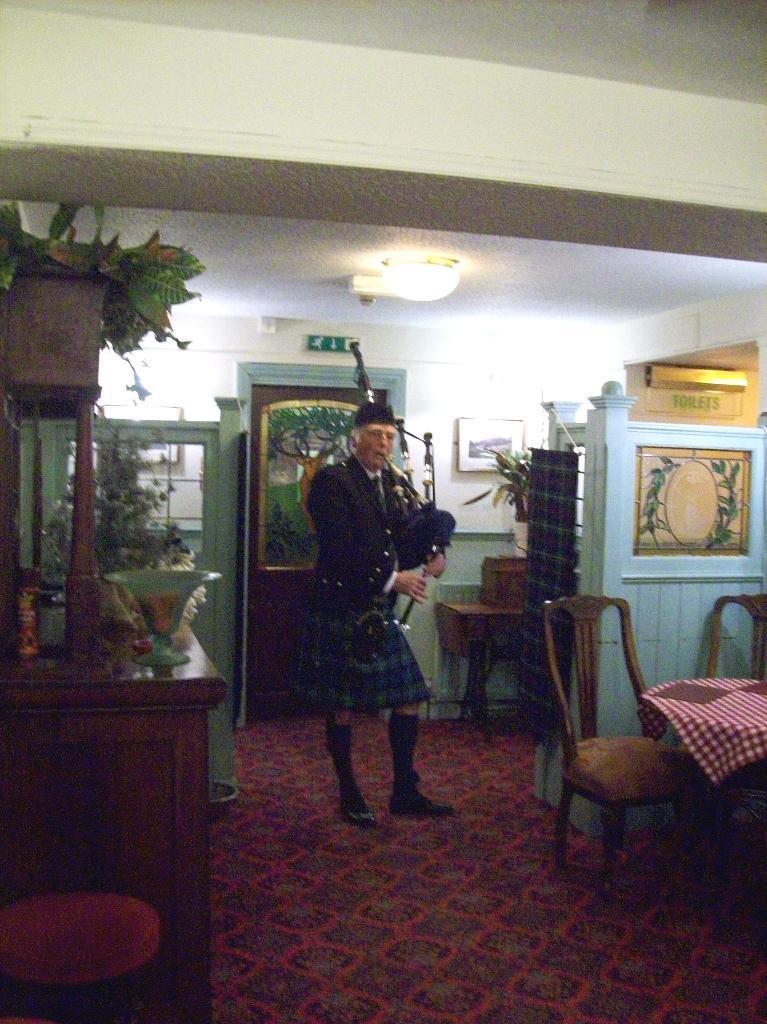How would you summarize this image in a sentence or two? In a picture a person is standing and wearing a different costume and playing a musical instrument there are chairs and tables near to them on the table there is a cloth there are some house plants on the table there is a light on the roof. 